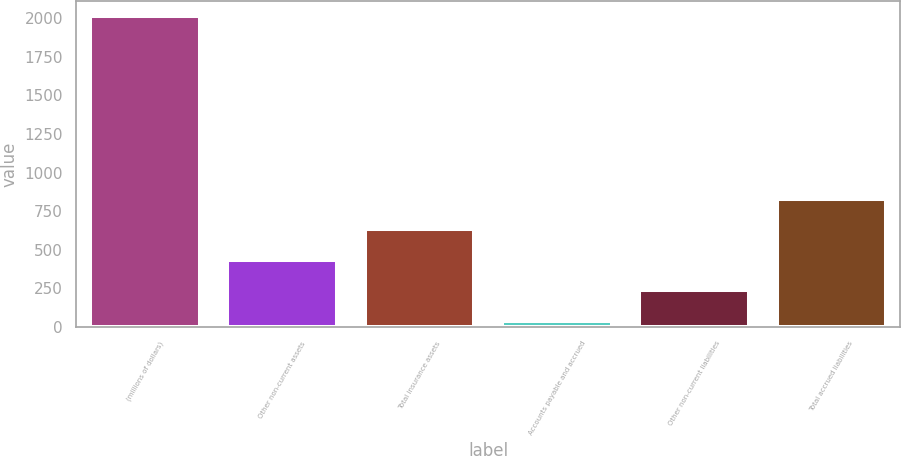Convert chart to OTSL. <chart><loc_0><loc_0><loc_500><loc_500><bar_chart><fcel>(millions of dollars)<fcel>Other non-current assets<fcel>Total insurance assets<fcel>Accounts payable and accrued<fcel>Other non-current liabilities<fcel>Total accrued liabilities<nl><fcel>2013<fcel>435.48<fcel>632.67<fcel>41.1<fcel>238.29<fcel>829.86<nl></chart> 